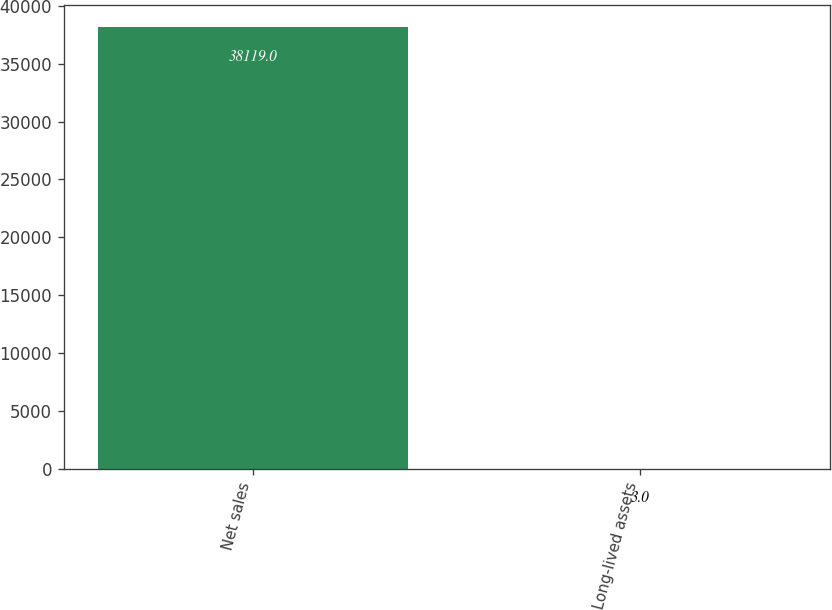<chart> <loc_0><loc_0><loc_500><loc_500><bar_chart><fcel>Net sales<fcel>Long-lived assets<nl><fcel>38119<fcel>3<nl></chart> 